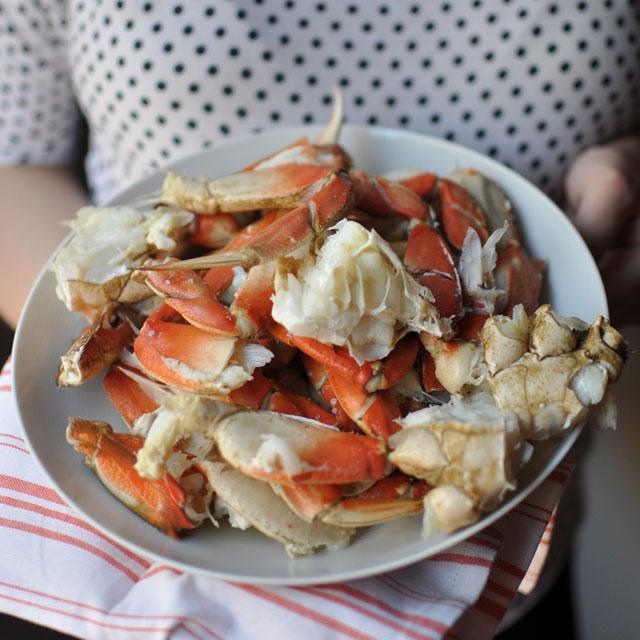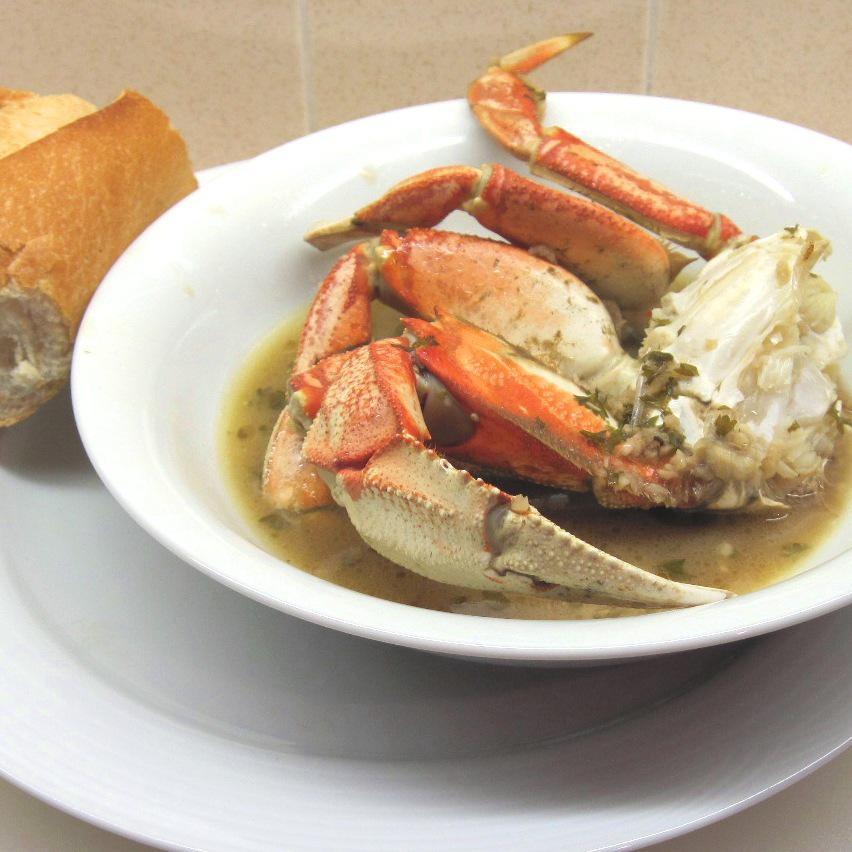The first image is the image on the left, the second image is the image on the right. Evaluate the accuracy of this statement regarding the images: "One of the dishes is a whole crab.". Is it true? Answer yes or no. No. The first image is the image on the left, the second image is the image on the right. Analyze the images presented: Is the assertion "The crab in one of the dishes sits in a bowl of liquid." valid? Answer yes or no. Yes. 